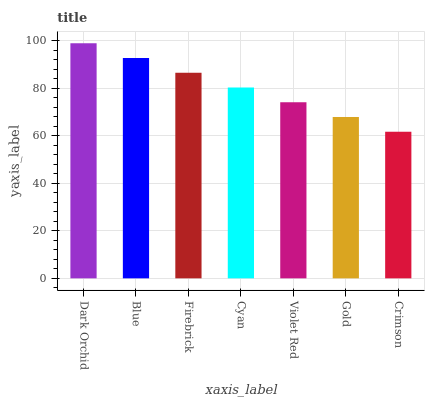Is Blue the minimum?
Answer yes or no. No. Is Blue the maximum?
Answer yes or no. No. Is Dark Orchid greater than Blue?
Answer yes or no. Yes. Is Blue less than Dark Orchid?
Answer yes or no. Yes. Is Blue greater than Dark Orchid?
Answer yes or no. No. Is Dark Orchid less than Blue?
Answer yes or no. No. Is Cyan the high median?
Answer yes or no. Yes. Is Cyan the low median?
Answer yes or no. Yes. Is Blue the high median?
Answer yes or no. No. Is Violet Red the low median?
Answer yes or no. No. 